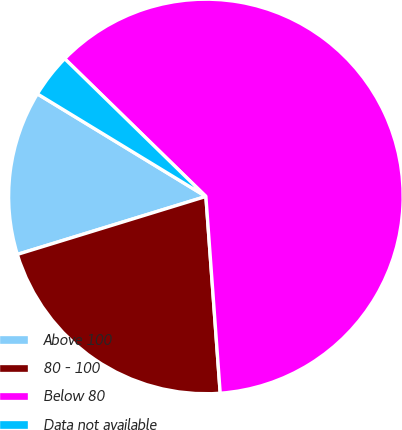Convert chart to OTSL. <chart><loc_0><loc_0><loc_500><loc_500><pie_chart><fcel>Above 100<fcel>80 - 100<fcel>Below 80<fcel>Data not available<nl><fcel>13.45%<fcel>21.41%<fcel>61.54%<fcel>3.6%<nl></chart> 